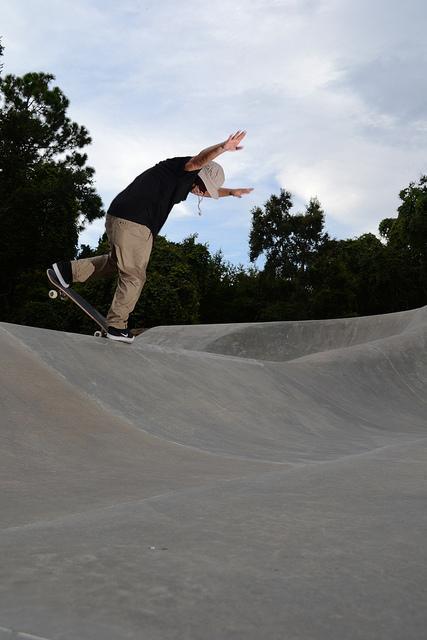How many people can be seen?
Give a very brief answer. 1. How many donuts are glazed?
Give a very brief answer. 0. 